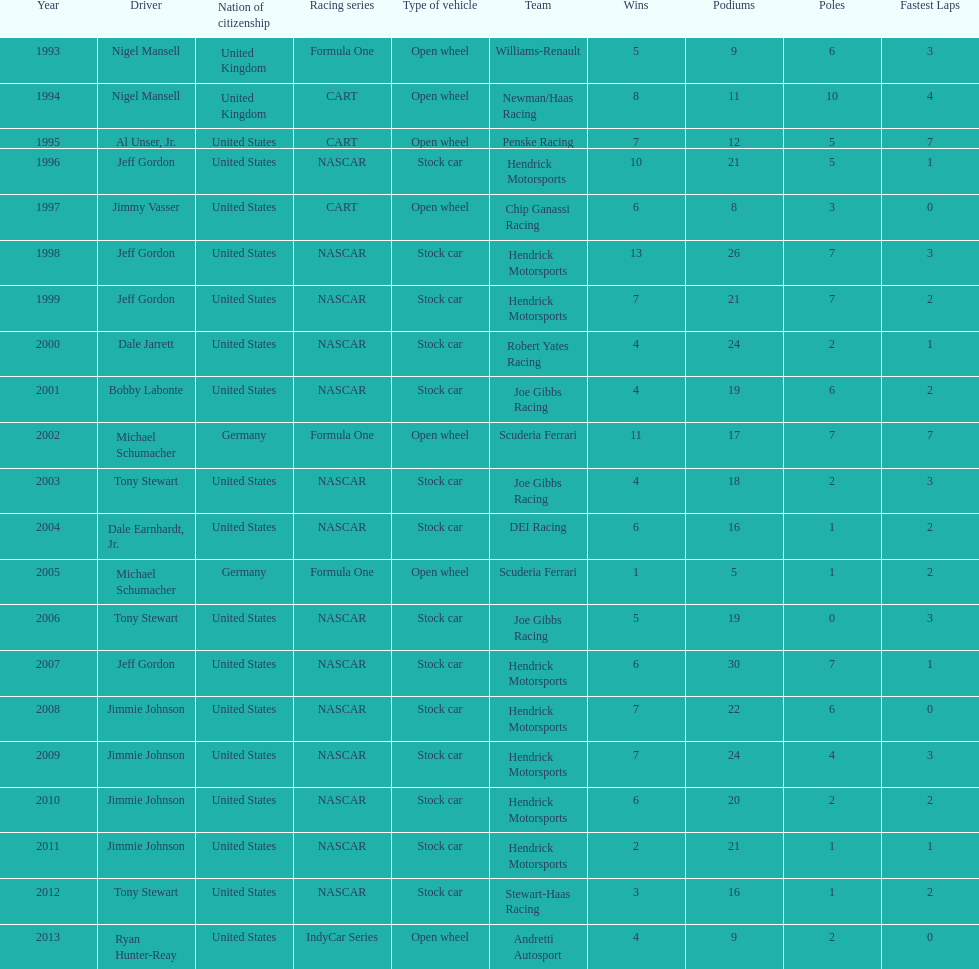Which driver won espy awards 11 years apart from each other? Jeff Gordon. 